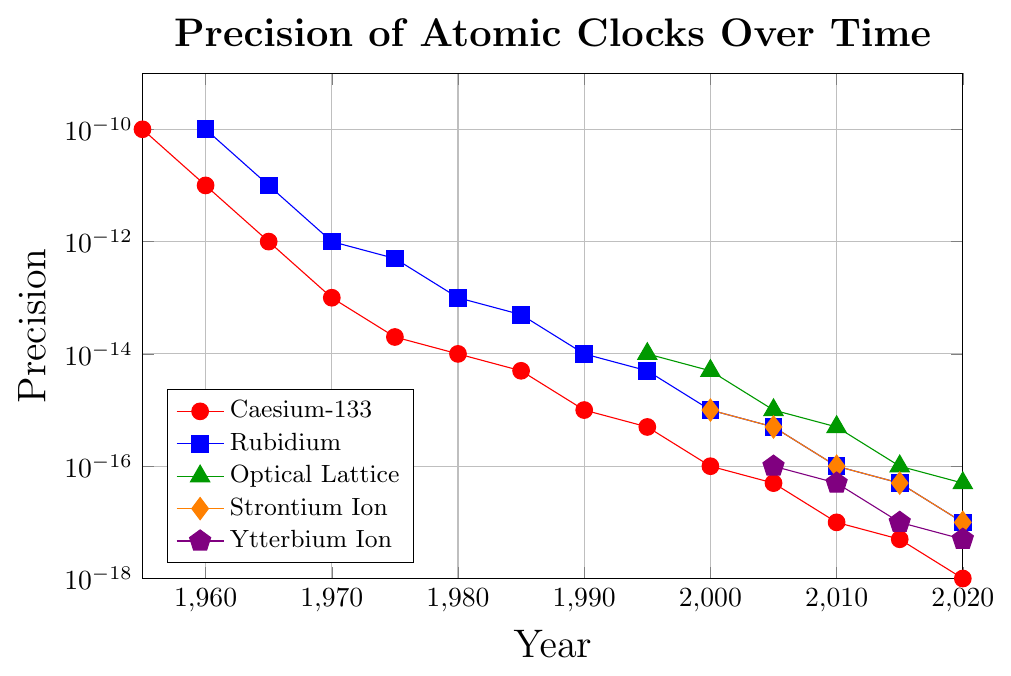What is the precision of the Caesium-133 clock in 1970? From the figure, find the line representing the Caesium-133 clock and look at the value corresponding to the year 1970.
Answer: 1e-13 How does the precision of the Rubidium clock compare to the Caesium-133 clock in 1980? Identify the data points for the Rubidium and Caesium-133 clocks for the year 1980. Caesium-133 has a precision of 1e-14 and Rubidium has a precision of 1e-13. Compare these values.
Answer: Caesium-133 has better precision than Rubidium What trend can be observed in the precision improvement of the Optical Lattice clock from 1995 to 2020? Examine the data points of the Optical Lattice clock. Note how the precision values change over time: From 1e-14 in 1995 to 5e-17 in 2020.
Answer: Precision improves significantly Which atomic clock type showed the first instance of precision better than 1e-15? Check the data points of each clock type over the years until you find the first precision value better than 1e-15.
Answer: Caesium-133 in 1990 Between 2000 and 2020, which type of clock shows the fastest improvement in precision? Compare the precision values of each clock type in the years 2000 and 2020. Calculate the difference and determine which has the largest improvement.
Answer: Caesium-133 In 2010, which atomic clock type had the second-best precision? Identify the precision values for all clock types in 2010. Rank the values to determine the second-best precision.
Answer: Strontium Ion How much did the precision of the Ytterbium Ion clock improve from 2005 to 2020? Note the precision values for Ytterbium Ion in 2005 and 2020. Calculate the difference: 1e-16 to 5e-18.
Answer: Improved by 9.5e-17 Between Caesium-133 and Rubidium clocks, which one had a consistently higher precision throughout the years? Compare the precision values of Caesium-133 and Rubidium for each year they both have data points. Determine which consistently has higher precision.
Answer: Caesium-133 In which year did the Strontium Ion clock equal the precision of the Rubidium clock? Locate the year in the figure where both Strontium Ion and Rubidium have the same precision value.
Answer: 2005 What is the gap in precision between the best and worst-performing clocks in 2020? Identify the highest and lowest precision values among all the clock types for 2020, and calculate the difference.
Answer: 9.5e-19 